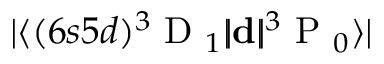Convert formula to latex. <formula><loc_0><loc_0><loc_500><loc_500>| \langle ( 6 s 5 d ) { { ^ { 3 } D _ { 1 } } } | \, | d | \, | { { ^ { 3 } P _ { 0 } } } \rangle |</formula> 